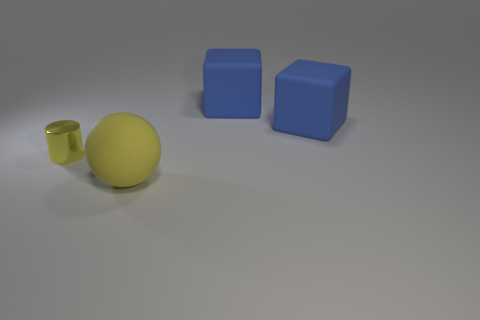What material is the big sphere that is in front of the small yellow shiny object?
Your answer should be very brief. Rubber. What number of other things are there of the same color as the tiny metal cylinder?
Your answer should be compact. 1. What color is the matte object that is in front of the small yellow cylinder?
Your answer should be very brief. Yellow. Are there any yellow matte objects that have the same size as the metal object?
Your response must be concise. No. What number of objects are either big blue rubber cubes that are behind the small yellow metallic cylinder or things in front of the yellow shiny thing?
Provide a short and direct response. 3. Are there any other small gray rubber objects of the same shape as the tiny object?
Your answer should be very brief. No. There is a ball that is the same color as the metal cylinder; what is it made of?
Offer a very short reply. Rubber. How many metallic objects are big blue blocks or gray things?
Make the answer very short. 0. There is a yellow rubber object; what shape is it?
Offer a very short reply. Sphere. How many large blue cubes have the same material as the big ball?
Your answer should be very brief. 2. 